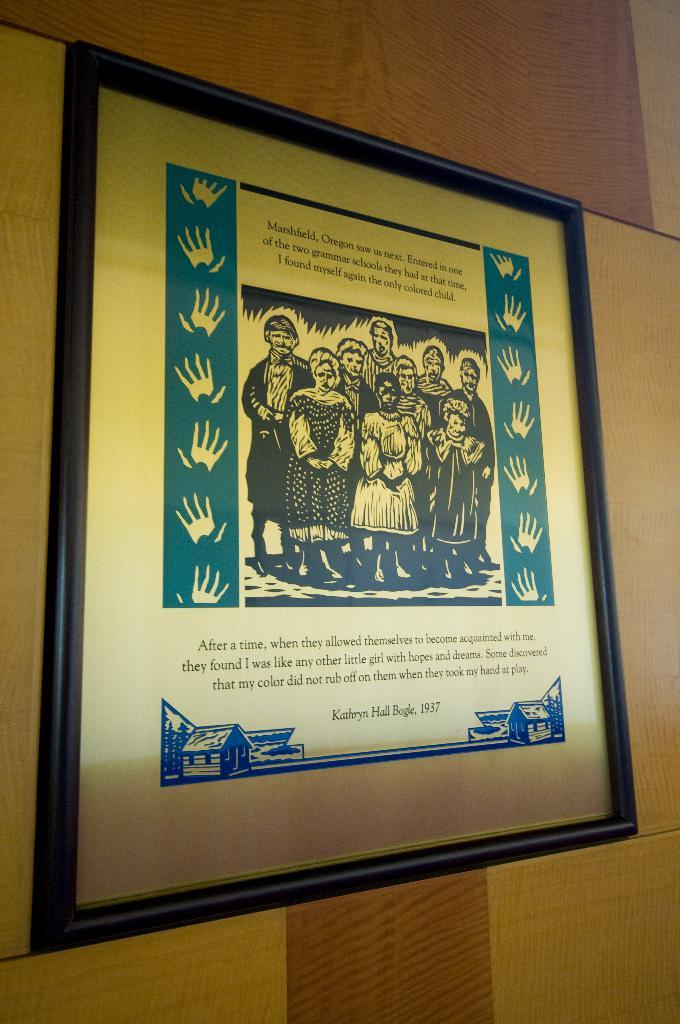<image>
Share a concise interpretation of the image provided. a framed picture with a group of people and a saying by Kathryn Hall Bogle 1937 